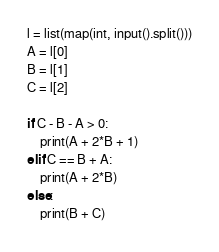Convert code to text. <code><loc_0><loc_0><loc_500><loc_500><_Python_>l = list(map(int, input().split()))
A = l[0]
B = l[1]
C = l[2]

if C - B - A > 0:
    print(A + 2*B + 1)
elif C == B + A:
    print(A + 2*B)
else:
    print(B + C)</code> 